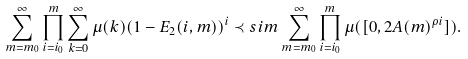Convert formula to latex. <formula><loc_0><loc_0><loc_500><loc_500>\sum _ { m = m _ { 0 } } ^ { \infty } \prod _ { i = i _ { 0 } } ^ { m } \sum _ { k = 0 } ^ { \infty } \mu ( k ) ( 1 - E _ { 2 } ( i , m ) ) ^ { i } \prec s i m \sum _ { m = m _ { 0 } } ^ { \infty } \prod _ { i = i _ { 0 } } ^ { m } \mu ( [ 0 , 2 A ( m ) ^ { { \rho } i } ] ) .</formula> 